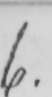What text is written in this handwritten line? 6 . 